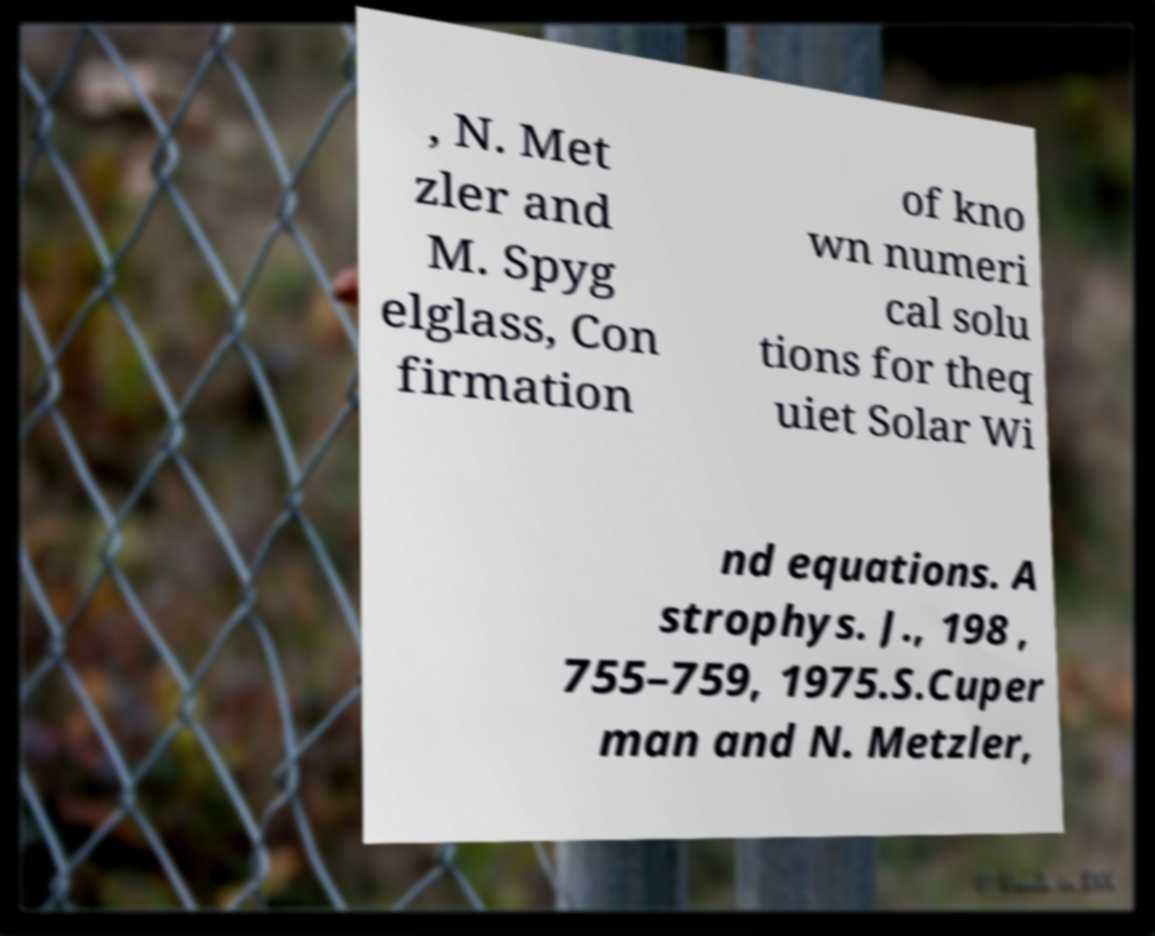Please read and relay the text visible in this image. What does it say? , N. Met zler and M. Spyg elglass, Con firmation of kno wn numeri cal solu tions for theq uiet Solar Wi nd equations. A strophys. J., 198 , 755–759, 1975.S.Cuper man and N. Metzler, 